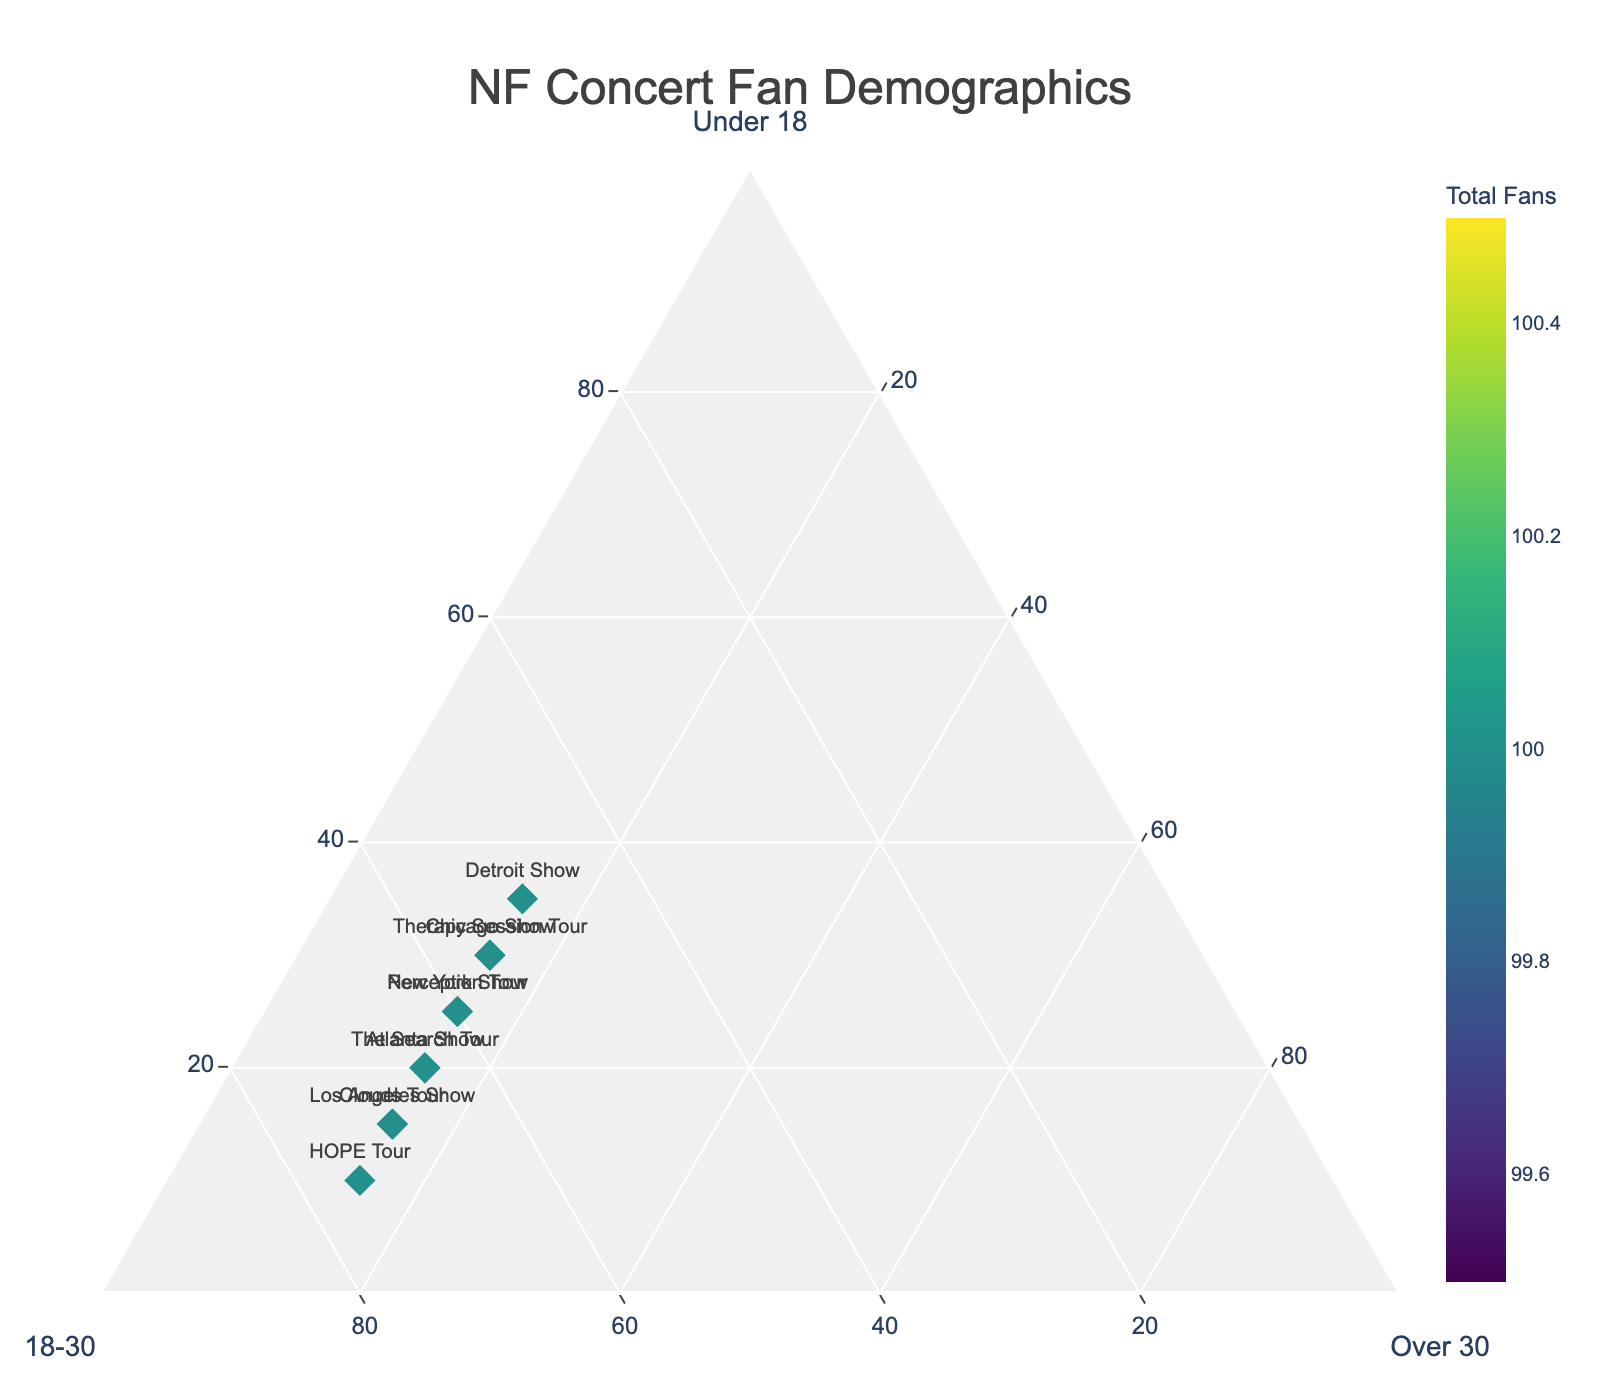How is the title of the plot displayed? Look at the font size and color of the title at the top center of the plot. It is written in a large font size with the text "NF Concert Fan Demographics".
Answer: "NF Concert Fan Demographics" Which concert has the highest percentage of fans aged 18-30? Locate the point in the ternary plot that is closer to the '18-30' axis. Hover over the points to see the specific percentages. The 'HOPE Tour' has the highest percentage listed for the 18-30 age group at 75%.
Answer: HOPE Tour What is the sum of percentages for fans under 18 and over 30 at the Los Angeles Show? Locate the Los Angeles Show point and check the percentages for 'Under 18' and 'Over 30'. Sum these values: 15% (Under 18) + 15% (Over 30) = 30%.
Answer: 30% Which concert has the smallest proportion of fans under 18? Check the 'Under 18' axis and identify the point farthest from it. By checking the values, we see that the 'HOPE Tour' has the smallest percentage of fans under 18 at 10%.
Answer: HOPE Tour How does the proportion of fans over 30 compare across all concerts? Look along the 'Over 30' axis and note that all concerts have the same proportion of fans over 30 at 15%.
Answer: Equal across all concerts What is the difference in the proportion of fans under 18 between the Therapy Session Tour and Clouds Tour? Check the 'Under 18' percentages for both tours. Therapy Session Tour has 30% while Clouds Tour has 15%. The difference is 30% - 15% = 15%.
Answer: 15% Which concert had the lowest total number of fans? Find the color bar indicating 'Total Fans' to see the color intensity corresponding to the total fan count. The lighter the color, the fewer the fans. The lowest color intensity corresponds to the 'HOPE Tour'.
Answer: HOPE Tour What concert has an equal distribution of fans across all three age groups? Identify the point where the percentages of 'Under 18', '18-30', and 'Over 30' are equal or nearly equal. None of the concerts have an equal distribution (each one has varying percentages).
Answer: None How are the axis labels positioned on the ternary plot? The axis labels 'Under 18', '18-30', and 'Over 30' are positioned respectively at the edges of the plot aligned with each axis direction. They are clearly marked in bold at the axes.
Answer: At the edges Which concerts had exactly 15% of fans over 30? Find the points on the plot where the 'Over 30' value is 15% by hovering over them. All listed concerts have 15% fans over 30, as indicated in the data.
Answer: All concerts 